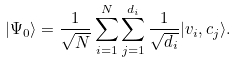Convert formula to latex. <formula><loc_0><loc_0><loc_500><loc_500>| \Psi _ { 0 } \rangle = \frac { 1 } { \sqrt { N } } \sum _ { i = 1 } ^ { N } \sum _ { j = 1 } ^ { d _ { i } } \frac { 1 } { \sqrt { d _ { i } } } | v _ { i } , c _ { j } \rangle .</formula> 